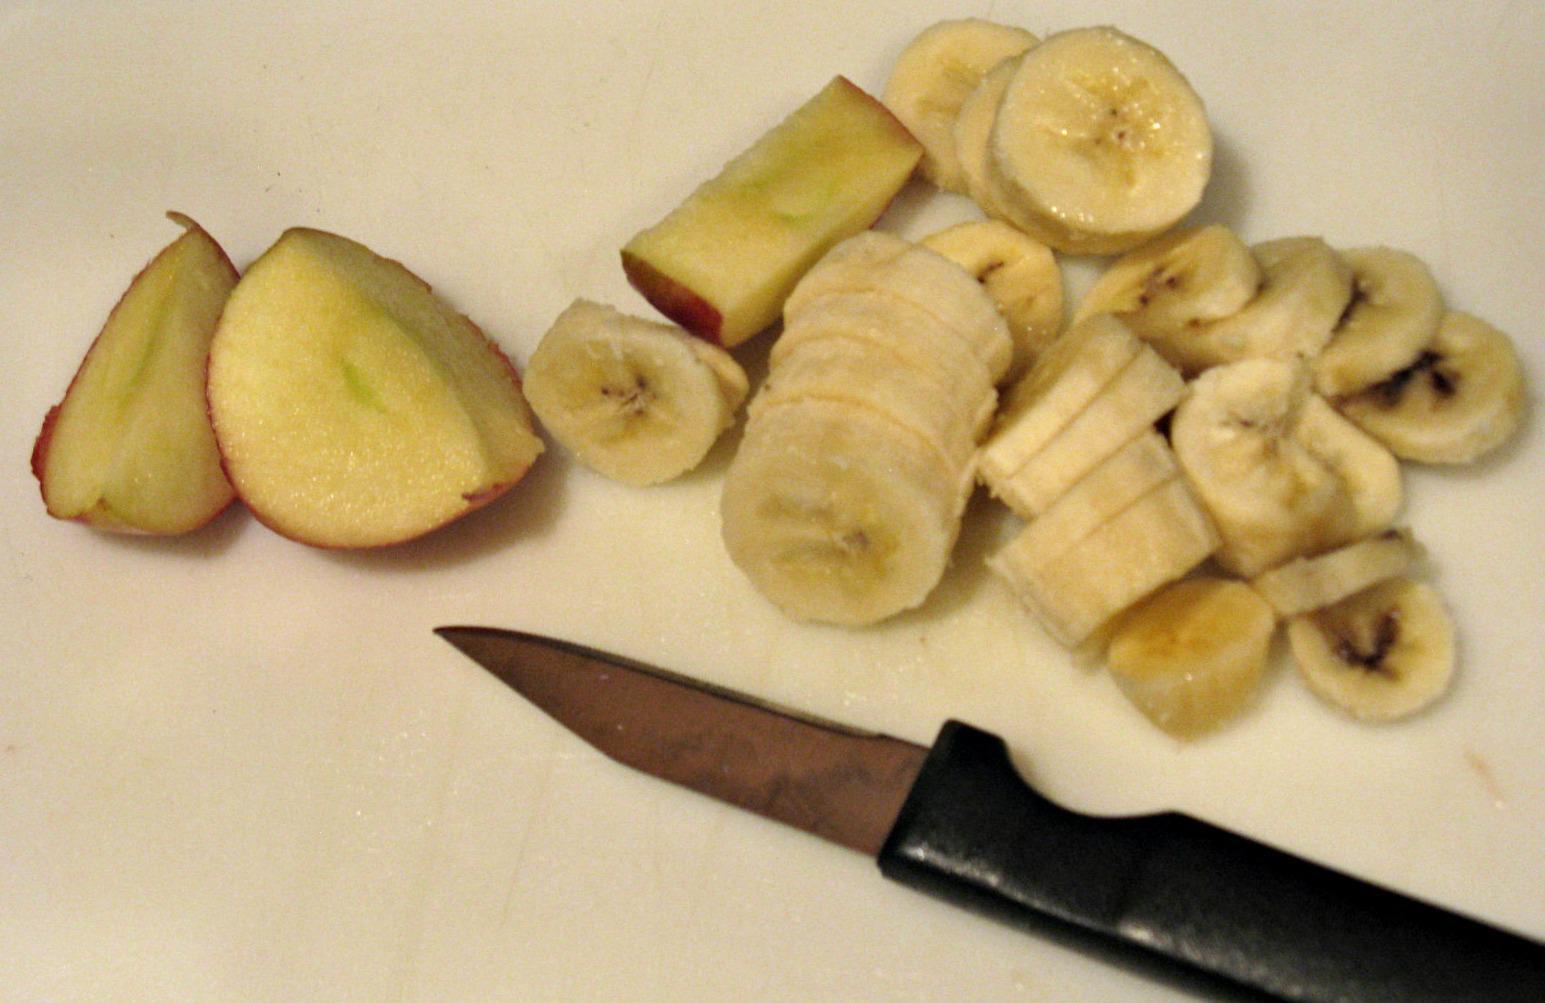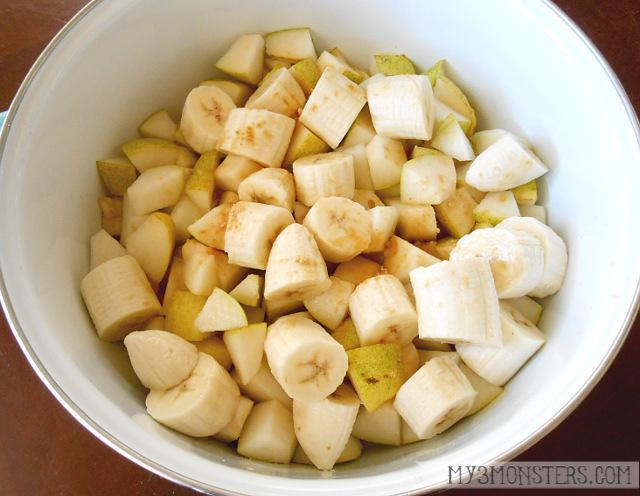The first image is the image on the left, the second image is the image on the right. Analyze the images presented: Is the assertion "In one image, a creamy drink is served with a garnish in a clear glass that is sitting near at least two unpeeled pieces of fruit." valid? Answer yes or no. No. The first image is the image on the left, the second image is the image on the right. Examine the images to the left and right. Is the description "A glass containing a straw in a creamy beverage is in front of unpeeled bananas." accurate? Answer yes or no. No. 